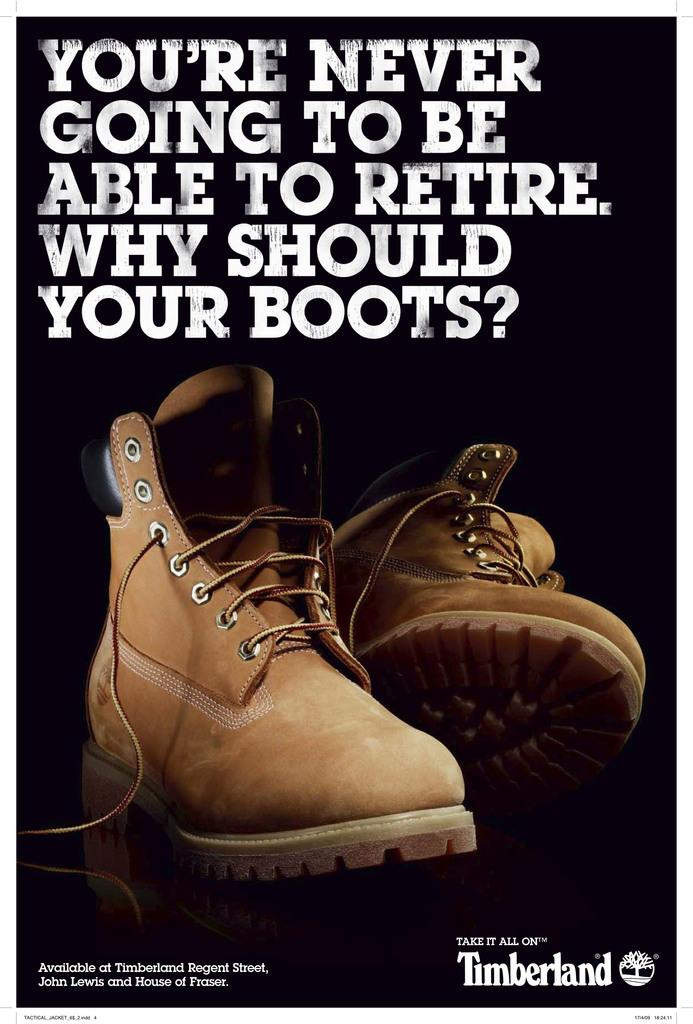What type of visual is the image? The image is a poster. What is shown on the poster? There are shoes depicted on the poster. Are there any words or letters on the poster? Yes, there is text present on the poster. Can you see any brushes or fangs on the poster? No, there are no brushes or fangs depicted on the poster; it features shoes and text. What type of station is shown on the poster? There is no station depicted on the poster; it focuses on shoes and text. 